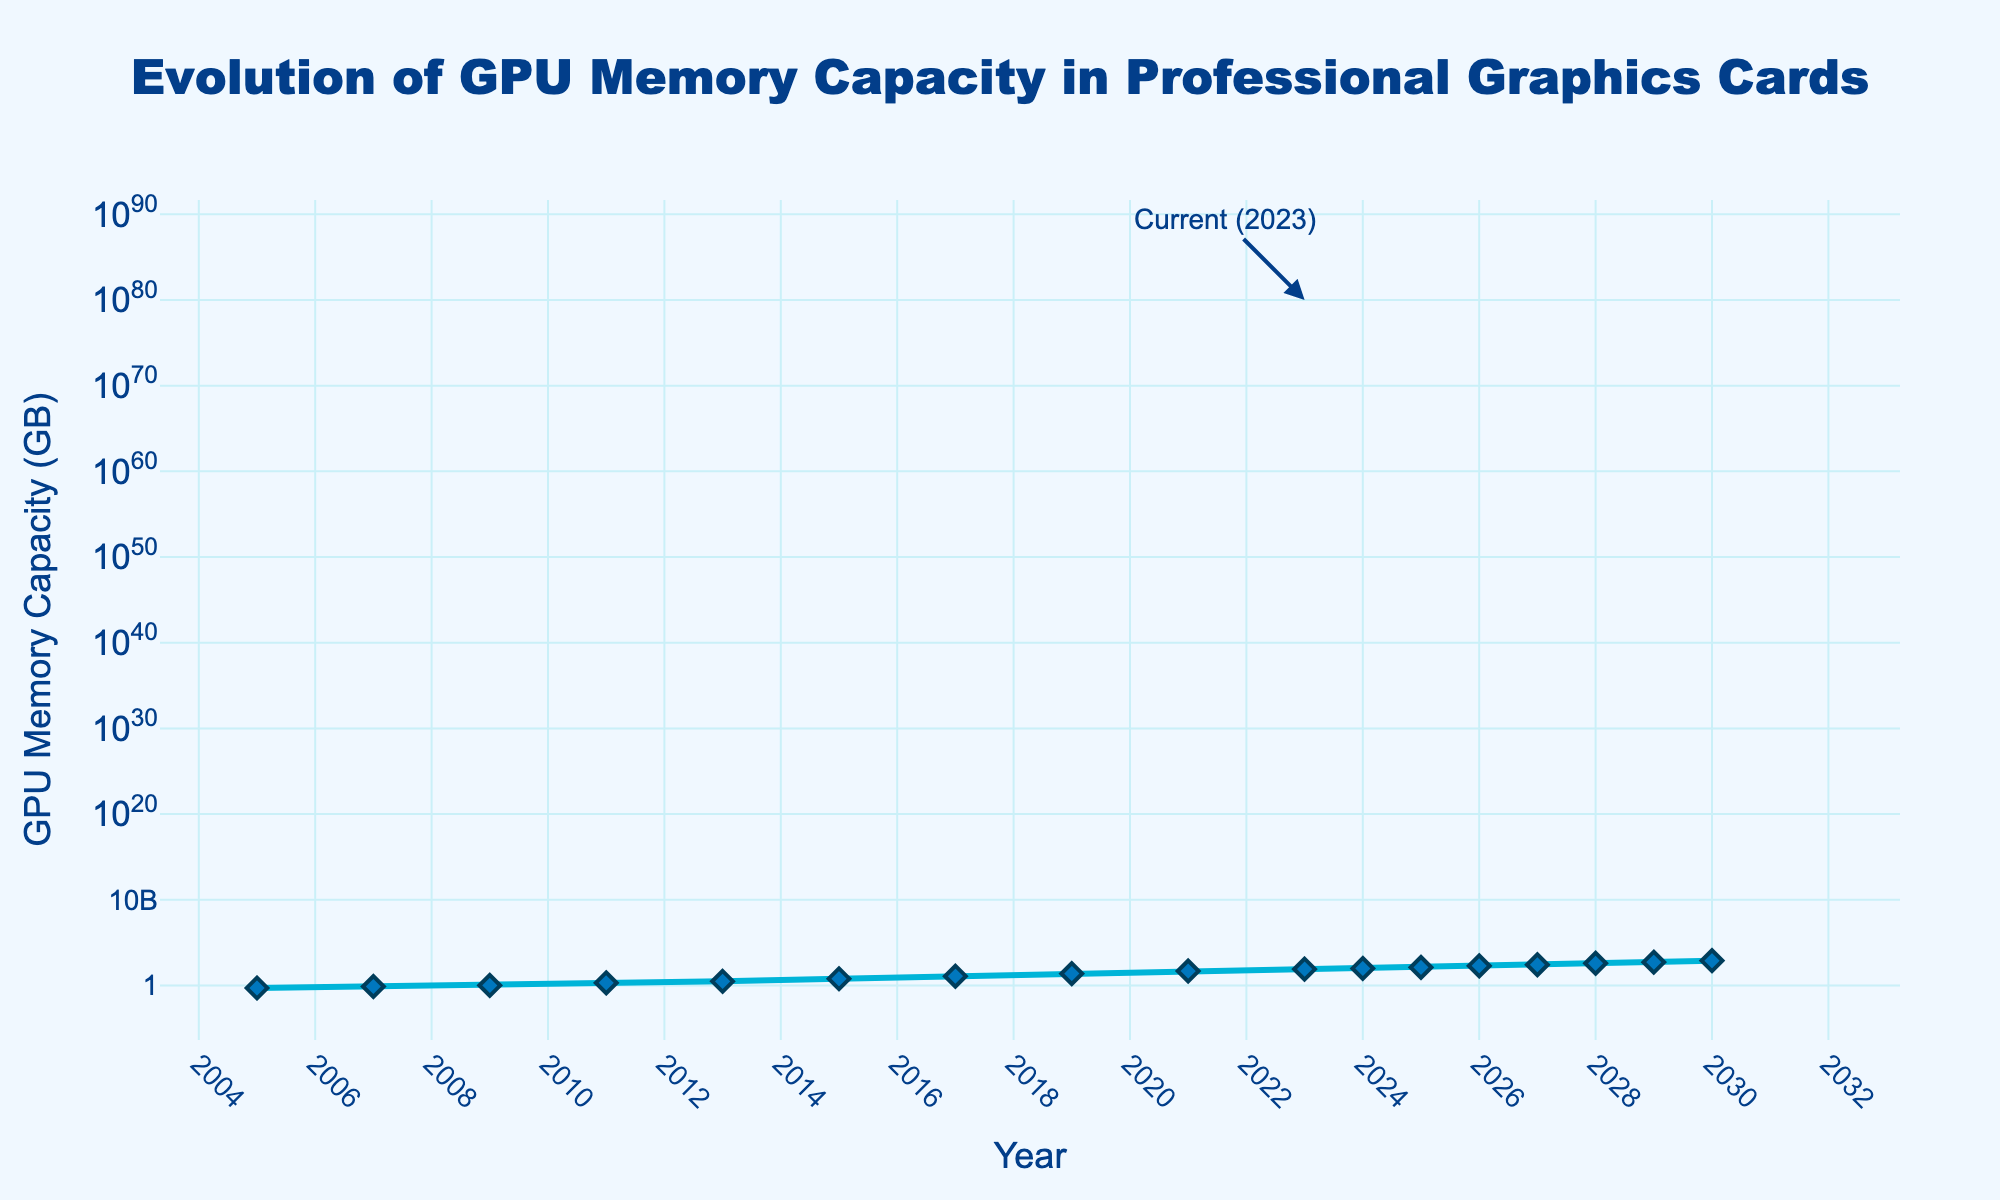what year did the GPU memory capacity reach 24 GB? Looking at the data points on the figure, the GPU memory capacity reached 24 GB in 2019.
Answer: 2019 How much did the GPU memory capacity increase between 2015 and 2017? In 2015, the memory was 6 GB, and in 2017, it was 12 GB. Thus, the increase is 12 - 6 = 6 GB.
Answer: 6 GB What is the projected GPU memory capacity for the year 2030? According to the annotation in the figure, the projected GPU memory capacity for 2030 is 768 GB.
Answer: 768 GB Between which years did the GPU memory capacity grow at the fastest rate? By comparing the slope of the line segments, the steepest incline is between 2023 and 2024, where the capacity increases by 16 GB.
Answer: 2023 to 2024 Which year saw a doubling of the previous year's GPU memory capacity for the first time? By observing the points, 2017 saw a doubling from the previous memory capacity in 2015 from 6 GB to 12 GB.
Answer: 2017 How many times did the GPU memory capacity increase by more than 100% from one point to the next? There are three instances of increases greater than 100%: from 6 GB (2015) to 12 GB (2017), from 48 GB (2021) to 80 GB (2023), and from 384 GB (2028) to 512 GB (2029).
Answer: 3 times What is the capacity of GPU memory in 2027, and how does it compare to that in 2026? The capacity in 2027 is 256 GB, while it was 192 GB in 2026. The 2027 capacity is greater by 256 - 192 = 64 GB.
Answer: 2027: 256 GB; Increase: 64 GB By how much did the GPU memory capacity grow between 2005 and 2015? Subtract the 2005 capacity (0.5 GB) from the 2015 capacity (6 GB): 6 - 0.5 = 5.5 GB.
Answer: 5.5 GB What's the average memory capacity for the years 2005, 2015, and 2023? Add the capacities (0.5 GB, 6 GB, 80 GB) and divide by 3: (0.5 + 6 + 80) / 3 = 86.5 / 3 ≈ 28.83 GB.
Answer: 28.83 GB What colors are used for the line and marker in the figure, and what does this signify about visual presentation? The line is blue, and the markers are dark blue diamonds, emphasizing the continuity and distinct data points.
Answer: Blue, Dark Blue 